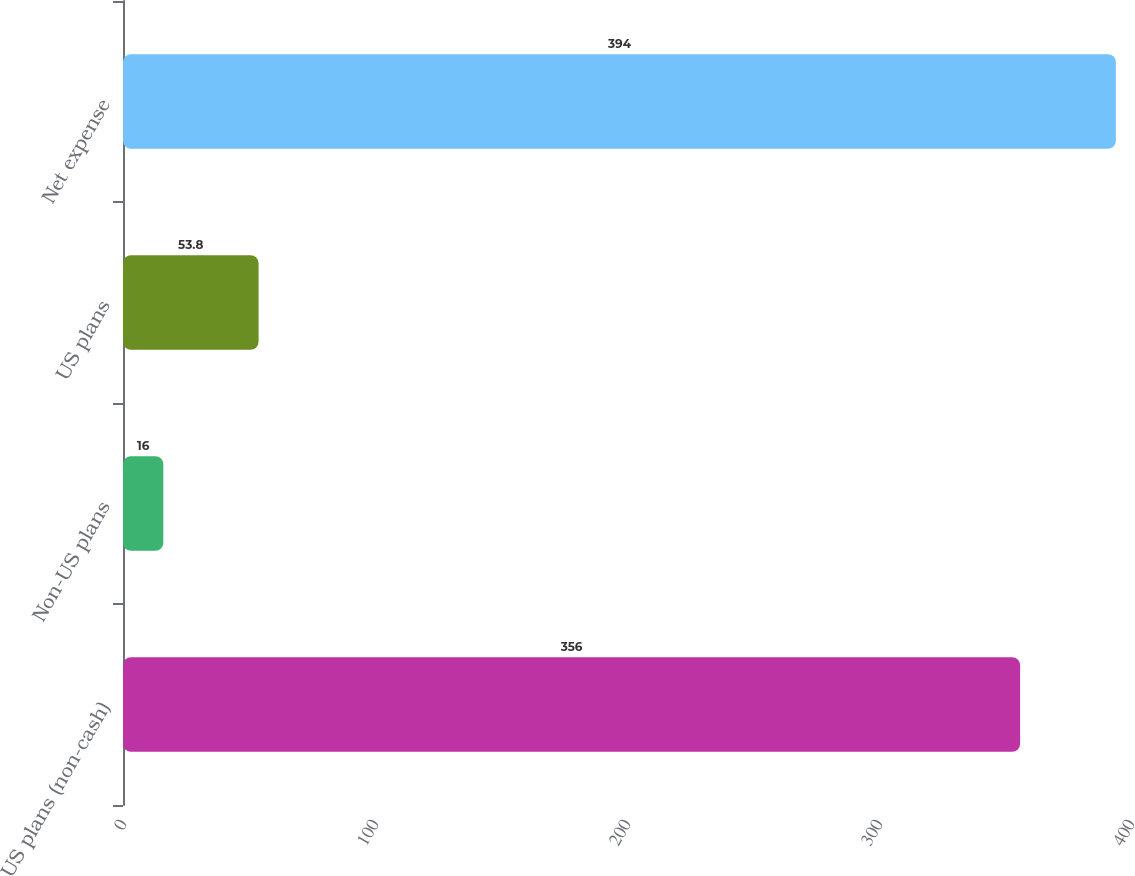<chart> <loc_0><loc_0><loc_500><loc_500><bar_chart><fcel>US plans (non-cash)<fcel>Non-US plans<fcel>US plans<fcel>Net expense<nl><fcel>356<fcel>16<fcel>53.8<fcel>394<nl></chart> 